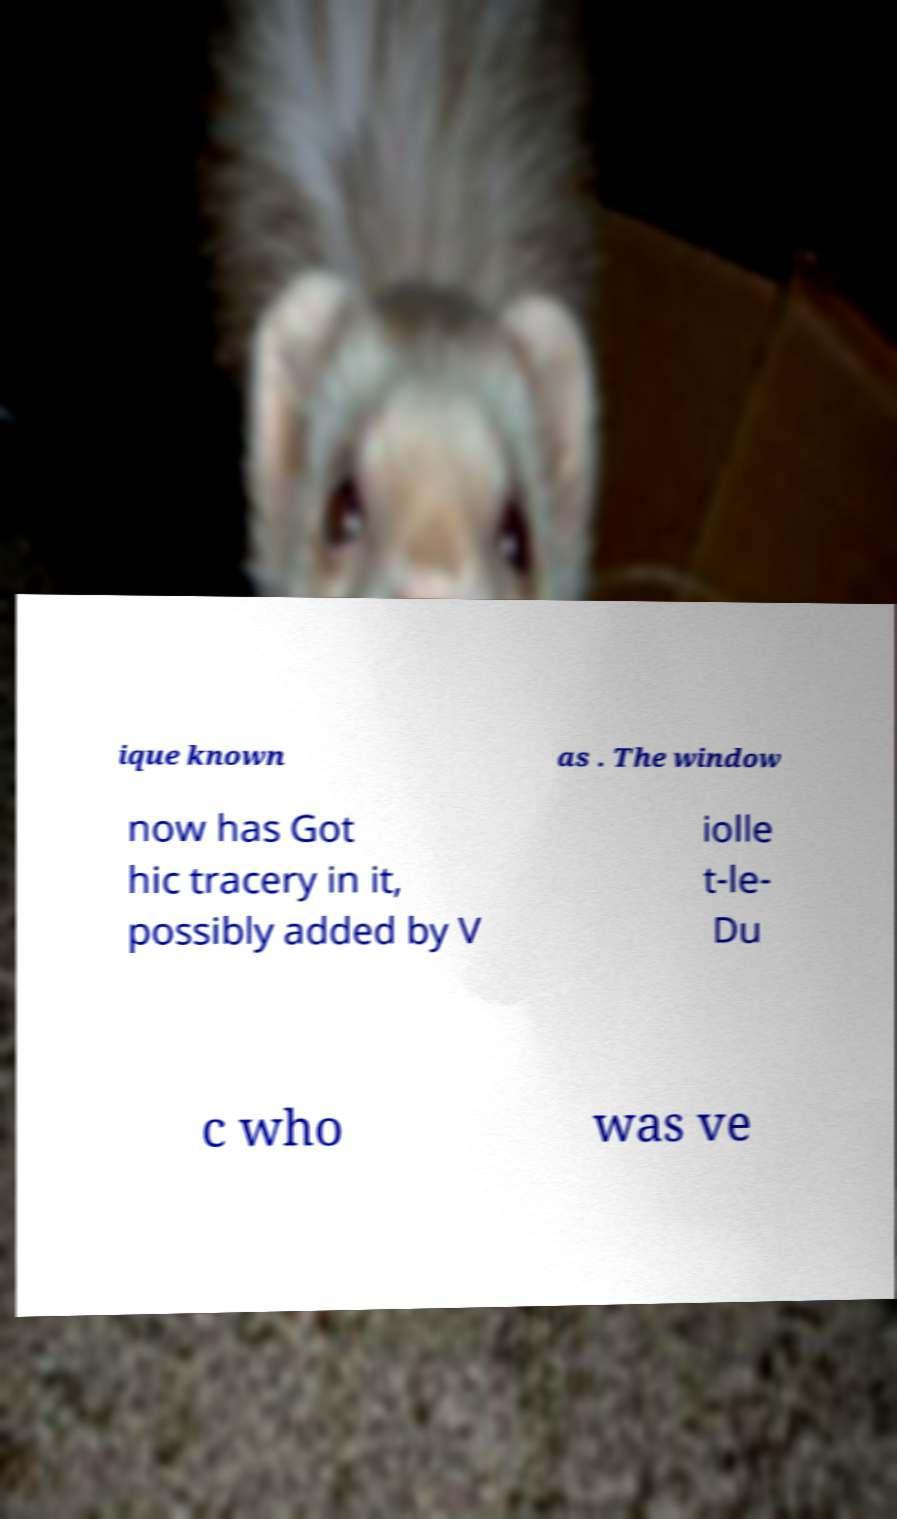Please read and relay the text visible in this image. What does it say? ique known as . The window now has Got hic tracery in it, possibly added by V iolle t-le- Du c who was ve 